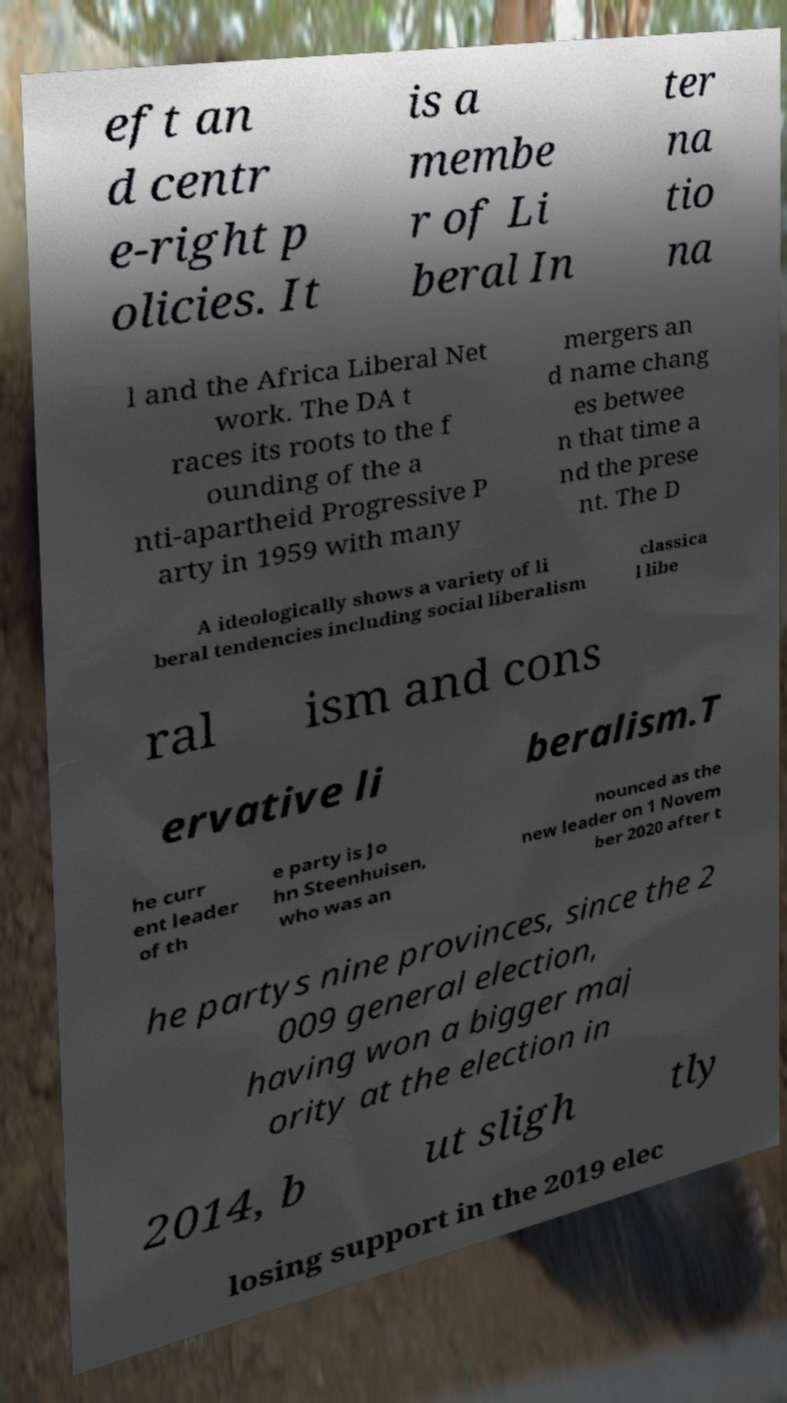There's text embedded in this image that I need extracted. Can you transcribe it verbatim? eft an d centr e-right p olicies. It is a membe r of Li beral In ter na tio na l and the Africa Liberal Net work. The DA t races its roots to the f ounding of the a nti-apartheid Progressive P arty in 1959 with many mergers an d name chang es betwee n that time a nd the prese nt. The D A ideologically shows a variety of li beral tendencies including social liberalism classica l libe ral ism and cons ervative li beralism.T he curr ent leader of th e party is Jo hn Steenhuisen, who was an nounced as the new leader on 1 Novem ber 2020 after t he partys nine provinces, since the 2 009 general election, having won a bigger maj ority at the election in 2014, b ut sligh tly losing support in the 2019 elec 